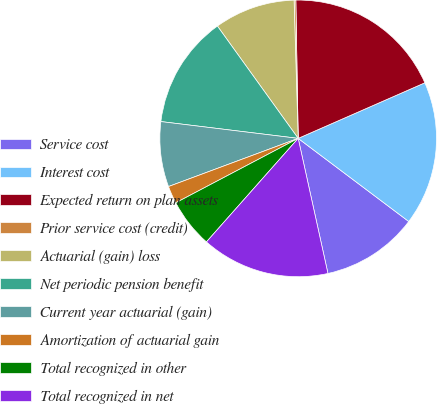<chart> <loc_0><loc_0><loc_500><loc_500><pie_chart><fcel>Service cost<fcel>Interest cost<fcel>Expected return on plan assets<fcel>Prior service cost (credit)<fcel>Actuarial (gain) loss<fcel>Net periodic pension benefit<fcel>Current year actuarial (gain)<fcel>Amortization of actuarial gain<fcel>Total recognized in other<fcel>Total recognized in net<nl><fcel>11.29%<fcel>16.84%<fcel>18.69%<fcel>0.2%<fcel>9.45%<fcel>13.14%<fcel>7.6%<fcel>2.05%<fcel>5.75%<fcel>14.99%<nl></chart> 